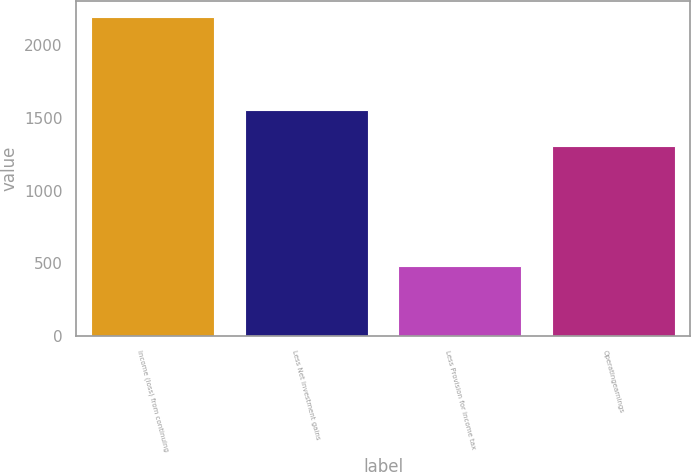<chart> <loc_0><loc_0><loc_500><loc_500><bar_chart><fcel>Income (loss) from continuing<fcel>Less Net investment gains<fcel>Less Provision for income tax<fcel>Operatingearnings<nl><fcel>2195<fcel>1558<fcel>480<fcel>1310<nl></chart> 